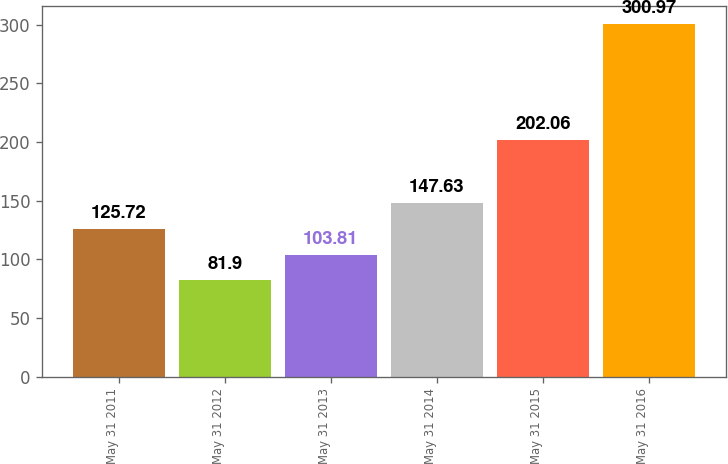Convert chart to OTSL. <chart><loc_0><loc_0><loc_500><loc_500><bar_chart><fcel>May 31 2011<fcel>May 31 2012<fcel>May 31 2013<fcel>May 31 2014<fcel>May 31 2015<fcel>May 31 2016<nl><fcel>125.72<fcel>81.9<fcel>103.81<fcel>147.63<fcel>202.06<fcel>300.97<nl></chart> 